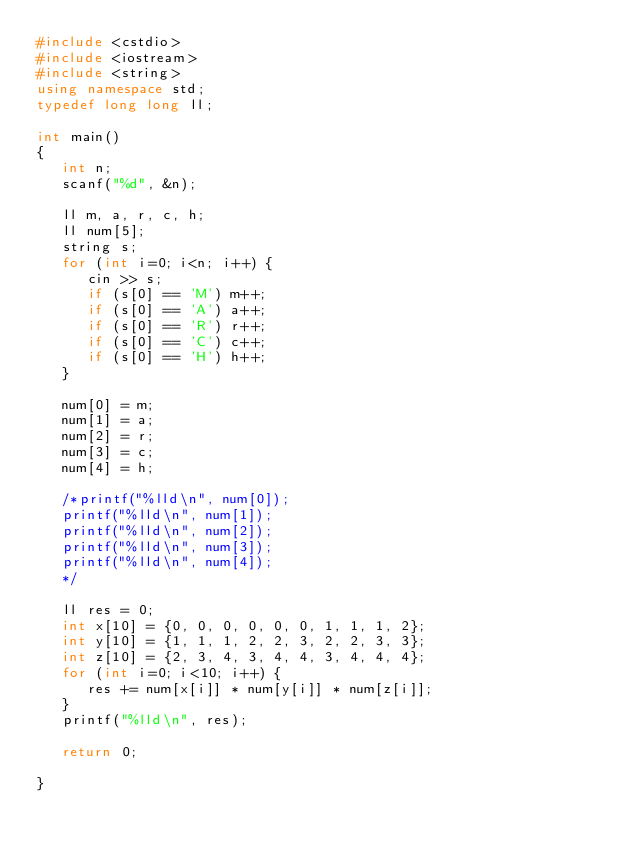Convert code to text. <code><loc_0><loc_0><loc_500><loc_500><_C++_>#include <cstdio>
#include <iostream>
#include <string>
using namespace std;
typedef long long ll;

int main()
{
   int n;
   scanf("%d", &n);

   ll m, a, r, c, h;
   ll num[5];
   string s;
   for (int i=0; i<n; i++) {
      cin >> s;
      if (s[0] == 'M') m++;
      if (s[0] == 'A') a++;
      if (s[0] == 'R') r++;
      if (s[0] == 'C') c++;
      if (s[0] == 'H') h++;
   }

   num[0] = m;
   num[1] = a;
   num[2] = r;
   num[3] = c;
   num[4] = h;

   /*printf("%lld\n", num[0]);
   printf("%lld\n", num[1]);
   printf("%lld\n", num[2]);
   printf("%lld\n", num[3]);
   printf("%lld\n", num[4]);
   */

   ll res = 0;
   int x[10] = {0, 0, 0, 0, 0, 0, 1, 1, 1, 2};
   int y[10] = {1, 1, 1, 2, 2, 3, 2, 2, 3, 3};
   int z[10] = {2, 3, 4, 3, 4, 4, 3, 4, 4, 4};
   for (int i=0; i<10; i++) {
      res += num[x[i]] * num[y[i]] * num[z[i]];
   }
   printf("%lld\n", res);

   return 0;

}

</code> 